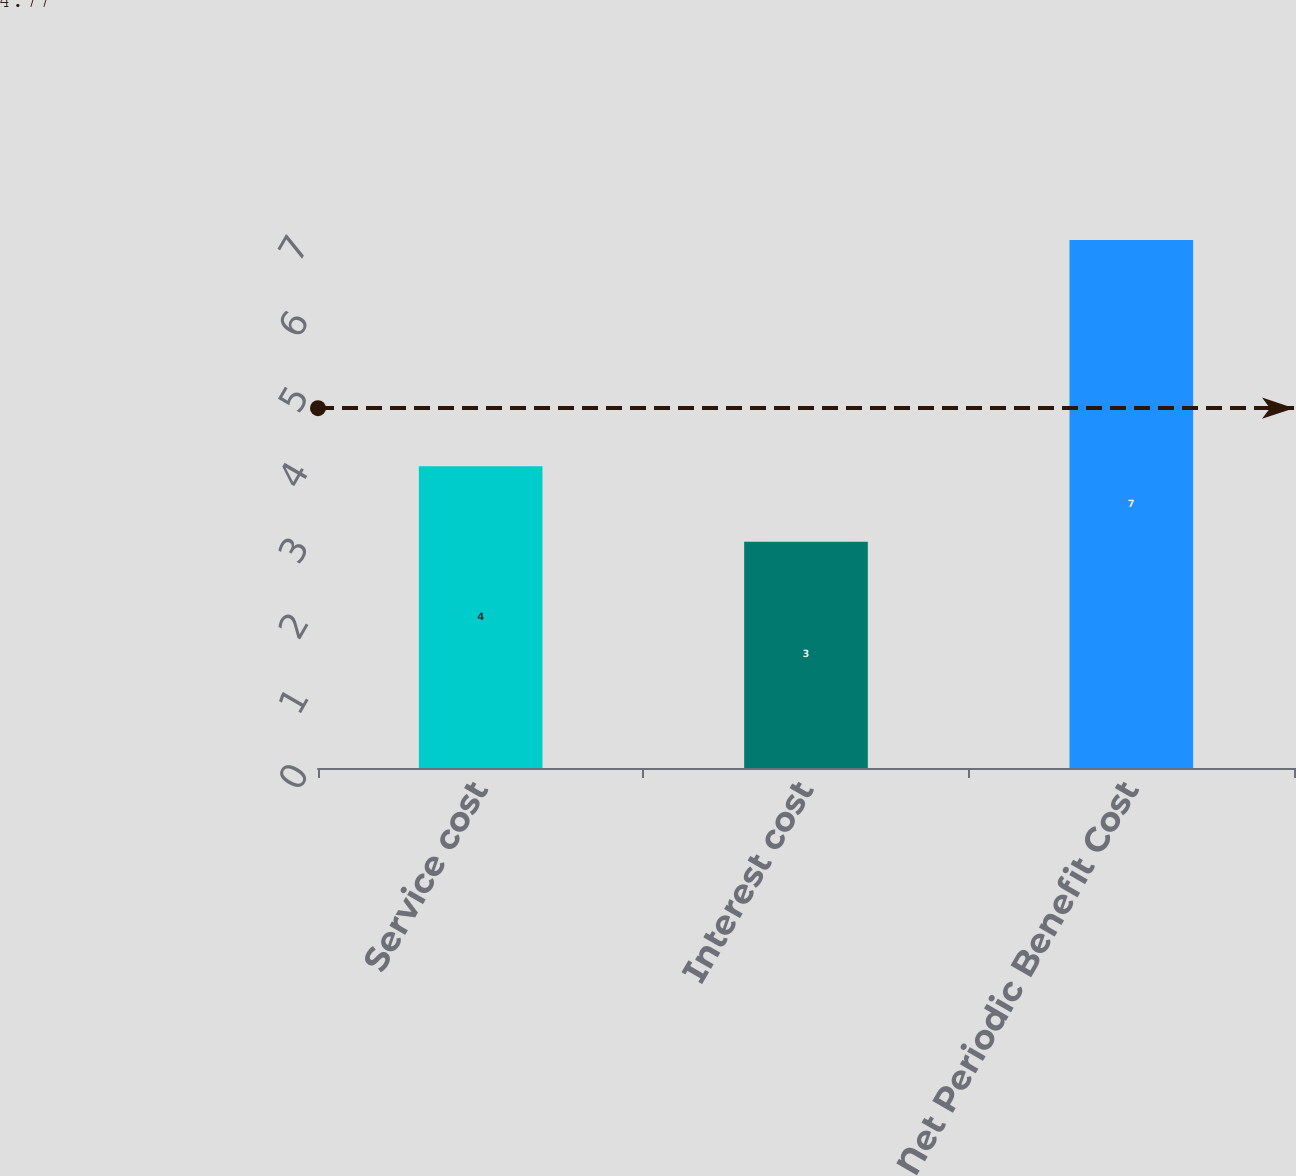Convert chart to OTSL. <chart><loc_0><loc_0><loc_500><loc_500><bar_chart><fcel>Service cost<fcel>Interest cost<fcel>Net Periodic Benefit Cost<nl><fcel>4<fcel>3<fcel>7<nl></chart> 